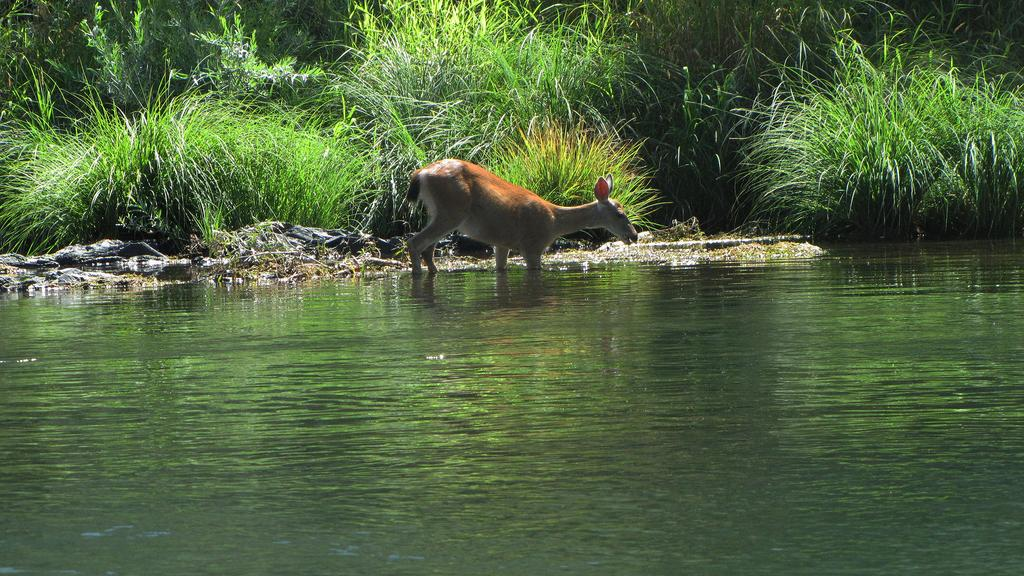What is in the water in the image? There is an animal in the water in the image. Can you describe the appearance of the animal? The animal is in brown and white color. What can be seen in the background of the image? There are plants and trees in the background of the image. What color are the plants and trees? The plants and trees are in green color. What type of property does the toad own in the image? There is no toad present in the image, and therefore no property ownership can be determined. In which direction is the north indicated in the image? There is no indication of direction, such as north, in the image. 